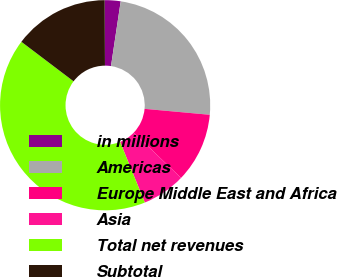Convert chart to OTSL. <chart><loc_0><loc_0><loc_500><loc_500><pie_chart><fcel>in millions<fcel>Americas<fcel>Europe Middle East and Africa<fcel>Asia<fcel>Total net revenues<fcel>Subtotal<nl><fcel>2.44%<fcel>24.08%<fcel>10.7%<fcel>6.69%<fcel>41.48%<fcel>14.61%<nl></chart> 